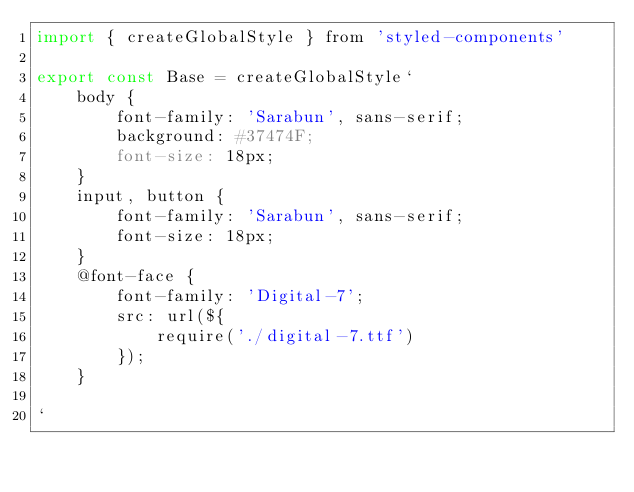<code> <loc_0><loc_0><loc_500><loc_500><_JavaScript_>import { createGlobalStyle } from 'styled-components'

export const Base = createGlobalStyle`
	body {
		font-family: 'Sarabun', sans-serif;
		background: #37474F;
		font-size: 18px;
	}
	input, button {
		font-family: 'Sarabun', sans-serif;
		font-size: 18px;
	}
	@font-face {
		font-family: 'Digital-7';
		src: url(${
			require('./digital-7.ttf')
		});
	}

` 
</code> 